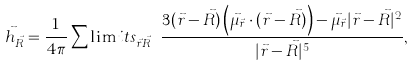Convert formula to latex. <formula><loc_0><loc_0><loc_500><loc_500>\vec { h } _ { \vec { R } } = \frac { 1 } { 4 \pi } \sum \lim i t s _ { \vec { r } \neq \vec { R } } { \frac { 3 ( \vec { r } - \vec { R } ) \left ( \vec { \mu } _ { \vec { r } } \cdot ( \vec { r } - \vec { R } ) \right ) - \vec { \mu } _ { \vec { r } } | \vec { r } - \vec { R } | ^ { 2 } } { | \vec { r } - \vec { R } | ^ { 5 } } } ,</formula> 